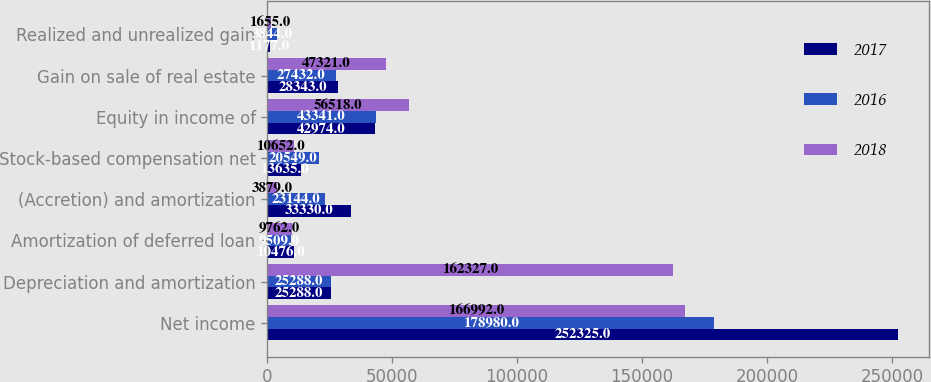Convert chart to OTSL. <chart><loc_0><loc_0><loc_500><loc_500><stacked_bar_chart><ecel><fcel>Net income<fcel>Depreciation and amortization<fcel>Amortization of deferred loan<fcel>(Accretion) and amortization<fcel>Stock-based compensation net<fcel>Equity in income of<fcel>Gain on sale of real estate<fcel>Realized and unrealized gain<nl><fcel>2017<fcel>252325<fcel>25288<fcel>10476<fcel>33330<fcel>13635<fcel>42974<fcel>28343<fcel>1177<nl><fcel>2016<fcel>178980<fcel>25288<fcel>9509<fcel>23144<fcel>20549<fcel>43341<fcel>27432<fcel>3844<nl><fcel>2018<fcel>166992<fcel>162327<fcel>9762<fcel>3879<fcel>10652<fcel>56518<fcel>47321<fcel>1655<nl></chart> 